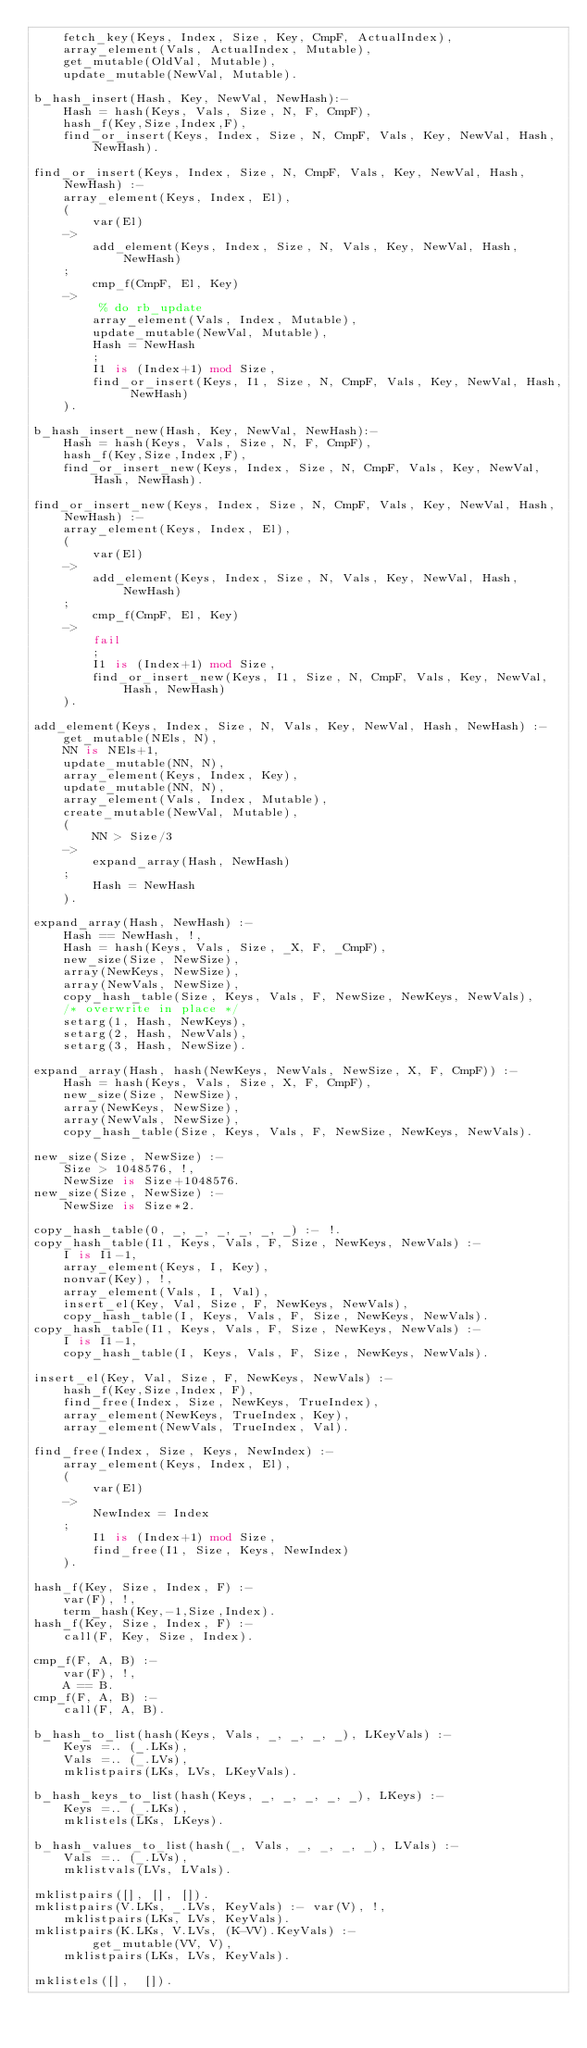Convert code to text. <code><loc_0><loc_0><loc_500><loc_500><_Prolog_>	fetch_key(Keys, Index, Size, Key, CmpF, ActualIndex),
	array_element(Vals, ActualIndex, Mutable),
	get_mutable(OldVal, Mutable),
	update_mutable(NewVal, Mutable).

b_hash_insert(Hash, Key, NewVal, NewHash):-
	Hash = hash(Keys, Vals, Size, N, F, CmpF),
	hash_f(Key,Size,Index,F),
	find_or_insert(Keys, Index, Size, N, CmpF, Vals, Key, NewVal, Hash, NewHash).

find_or_insert(Keys, Index, Size, N, CmpF, Vals, Key, NewVal, Hash, NewHash) :-
	array_element(Keys, Index, El),
	(
	    var(El)
	->
	    add_element(Keys, Index, Size, N, Vals, Key, NewVal, Hash, NewHash)
	;
	    cmp_f(CmpF, El, Key)
	->
	     % do rb_update
	    array_element(Vals, Index, Mutable),
	    update_mutable(NewVal, Mutable),
	    Hash = NewHash
        ;
	    I1 is (Index+1) mod Size,
	    find_or_insert(Keys, I1, Size, N, CmpF, Vals, Key, NewVal, Hash, NewHash)
	).

b_hash_insert_new(Hash, Key, NewVal, NewHash):-
	Hash = hash(Keys, Vals, Size, N, F, CmpF),
	hash_f(Key,Size,Index,F),
	find_or_insert_new(Keys, Index, Size, N, CmpF, Vals, Key, NewVal, Hash, NewHash).

find_or_insert_new(Keys, Index, Size, N, CmpF, Vals, Key, NewVal, Hash, NewHash) :-
	array_element(Keys, Index, El),
	(
	    var(El)
	->
	    add_element(Keys, Index, Size, N, Vals, Key, NewVal, Hash, NewHash)
	;
	    cmp_f(CmpF, El, Key)
	->
	    fail
        ;
	    I1 is (Index+1) mod Size,
	    find_or_insert_new(Keys, I1, Size, N, CmpF, Vals, Key, NewVal, Hash, NewHash)
	).

add_element(Keys, Index, Size, N, Vals, Key, NewVal, Hash, NewHash) :-
	get_mutable(NEls, N),
	NN is NEls+1,
	update_mutable(NN, N),
	array_element(Keys, Index, Key),
	update_mutable(NN, N),
	array_element(Vals, Index, Mutable),
	create_mutable(NewVal, Mutable),
	(
	    NN > Size/3
	->
	    expand_array(Hash, NewHash)
	;
	    Hash = NewHash
	).

expand_array(Hash, NewHash) :-
	Hash == NewHash, !,
	Hash = hash(Keys, Vals, Size, _X, F, _CmpF),
	new_size(Size, NewSize),
	array(NewKeys, NewSize),
	array(NewVals, NewSize),
	copy_hash_table(Size, Keys, Vals, F, NewSize, NewKeys, NewVals),
	/* overwrite in place */
	setarg(1, Hash, NewKeys),
	setarg(2, Hash, NewVals),
	setarg(3, Hash, NewSize).

expand_array(Hash, hash(NewKeys, NewVals, NewSize, X, F, CmpF)) :-
	Hash = hash(Keys, Vals, Size, X, F, CmpF),
	new_size(Size, NewSize),
	array(NewKeys, NewSize),
	array(NewVals, NewSize),
	copy_hash_table(Size, Keys, Vals, F, NewSize, NewKeys, NewVals).

new_size(Size, NewSize) :-
	Size > 1048576, !,
	NewSize is Size+1048576.
new_size(Size, NewSize) :-
	NewSize is Size*2.

copy_hash_table(0, _, _, _, _, _, _) :- !.
copy_hash_table(I1, Keys, Vals, F, Size, NewKeys, NewVals) :-
	I is I1-1,
	array_element(Keys, I, Key),
	nonvar(Key), !,
	array_element(Vals, I, Val),
	insert_el(Key, Val, Size, F, NewKeys, NewVals),
	copy_hash_table(I, Keys, Vals, F, Size, NewKeys, NewVals).
copy_hash_table(I1, Keys, Vals, F, Size, NewKeys, NewVals) :-
	I is I1-1,
	copy_hash_table(I, Keys, Vals, F, Size, NewKeys, NewVals).

insert_el(Key, Val, Size, F, NewKeys, NewVals) :-
	hash_f(Key,Size,Index, F),
	find_free(Index, Size, NewKeys, TrueIndex),
	array_element(NewKeys, TrueIndex, Key),
	array_element(NewVals, TrueIndex, Val).

find_free(Index, Size, Keys, NewIndex) :-
	array_element(Keys, Index, El),
	(
	    var(El)
	->
	    NewIndex = Index
	;
	    I1 is (Index+1) mod Size,
	    find_free(I1, Size, Keys, NewIndex)
	).

hash_f(Key, Size, Index, F) :-
	var(F), !,
	term_hash(Key,-1,Size,Index).
hash_f(Key, Size, Index, F) :-
	call(F, Key, Size, Index).

cmp_f(F, A, B) :-
	var(F), !,
	A == B.
cmp_f(F, A, B) :-
	call(F, A, B).

b_hash_to_list(hash(Keys, Vals, _, _, _, _), LKeyVals) :-
	Keys =.. (_.LKs),
	Vals =.. (_.LVs),
	mklistpairs(LKs, LVs, LKeyVals).

b_hash_keys_to_list(hash(Keys, _, _, _, _, _), LKeys) :-
	Keys =.. (_.LKs),
	mklistels(LKs, LKeys).

b_hash_values_to_list(hash(_, Vals, _, _, _, _), LVals) :-
	Vals =.. (_.LVs),
	mklistvals(LVs, LVals).

mklistpairs([], [], []).
mklistpairs(V.LKs, _.LVs, KeyVals) :- var(V), !,
	mklistpairs(LKs, LVs, KeyVals).
mklistpairs(K.LKs, V.LVs, (K-VV).KeyVals) :- 
        get_mutable(VV, V),
	mklistpairs(LKs, LVs, KeyVals).

mklistels([],  []).</code> 